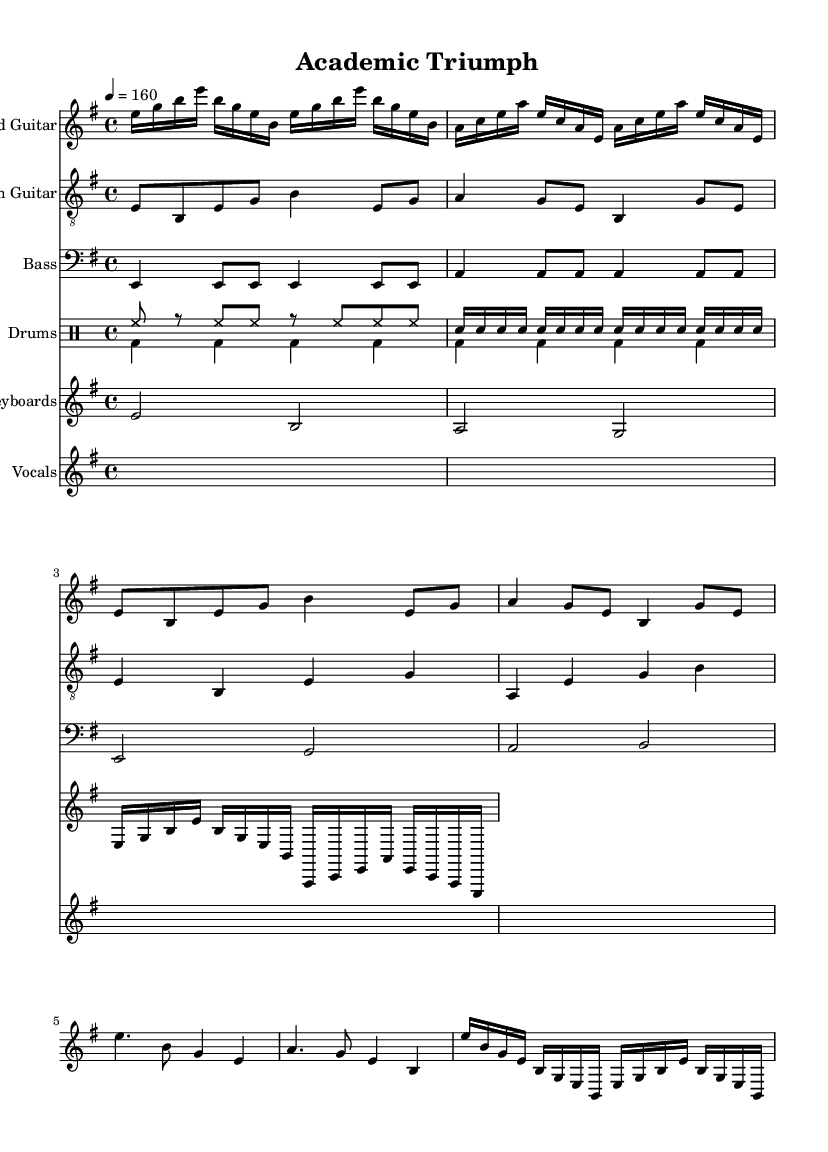What is the key signature of this music? The key signature is E minor, which has one sharp (F#) and is indicated at the beginning of the staff lines.
Answer: E minor What is the time signature of this music? The time signature is 4/4, which indicates that there are four beats in each measure and a quarter note gets one beat. This is shown at the beginning of the sheet music.
Answer: 4/4 What is the tempo marking for the piece? The tempo marking is 160 beats per minute, denoted by the term "4 = 160" which indicates the speed at which the music should be played.
Answer: 160 How many measures are in the intro section? The intro section consists of 4 measures, which can be counted from the start of the lead guitar part until the transition into the verse.
Answer: 4 Which instrument plays the main riff of the song? The main riff of the song is played by the rhythm guitar, as indicated in the sheet music under the rhythm guitar staff.
Answer: Rhythm guitar What is the lyrical theme of the piece? The lyrics express themes of overcoming academic challenges and perseverance through difficult times, which is evident from the phrases about "facing dead lines" and "endless fights".
Answer: Overcoming academic challenges What sort of musical fills are used in the drums? The drums incorporate basic beats with snare fills in the up drum part, as shown in the drumming notation indicating snare hits in rapid succession.
Answer: Snare fills 